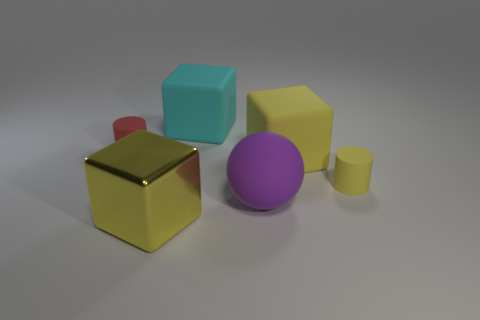How many other purple balls have the same material as the purple ball? Upon examining the image, there are no other purple balls present. Therefore, the purple ball is unique in its color and material. 